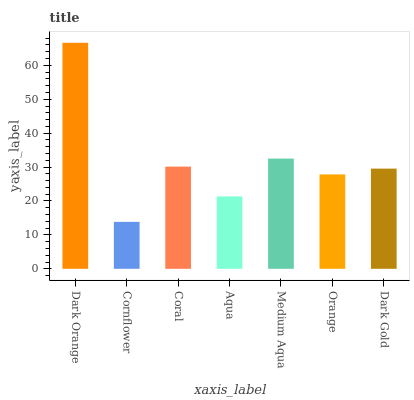Is Cornflower the minimum?
Answer yes or no. Yes. Is Dark Orange the maximum?
Answer yes or no. Yes. Is Coral the minimum?
Answer yes or no. No. Is Coral the maximum?
Answer yes or no. No. Is Coral greater than Cornflower?
Answer yes or no. Yes. Is Cornflower less than Coral?
Answer yes or no. Yes. Is Cornflower greater than Coral?
Answer yes or no. No. Is Coral less than Cornflower?
Answer yes or no. No. Is Dark Gold the high median?
Answer yes or no. Yes. Is Dark Gold the low median?
Answer yes or no. Yes. Is Dark Orange the high median?
Answer yes or no. No. Is Cornflower the low median?
Answer yes or no. No. 